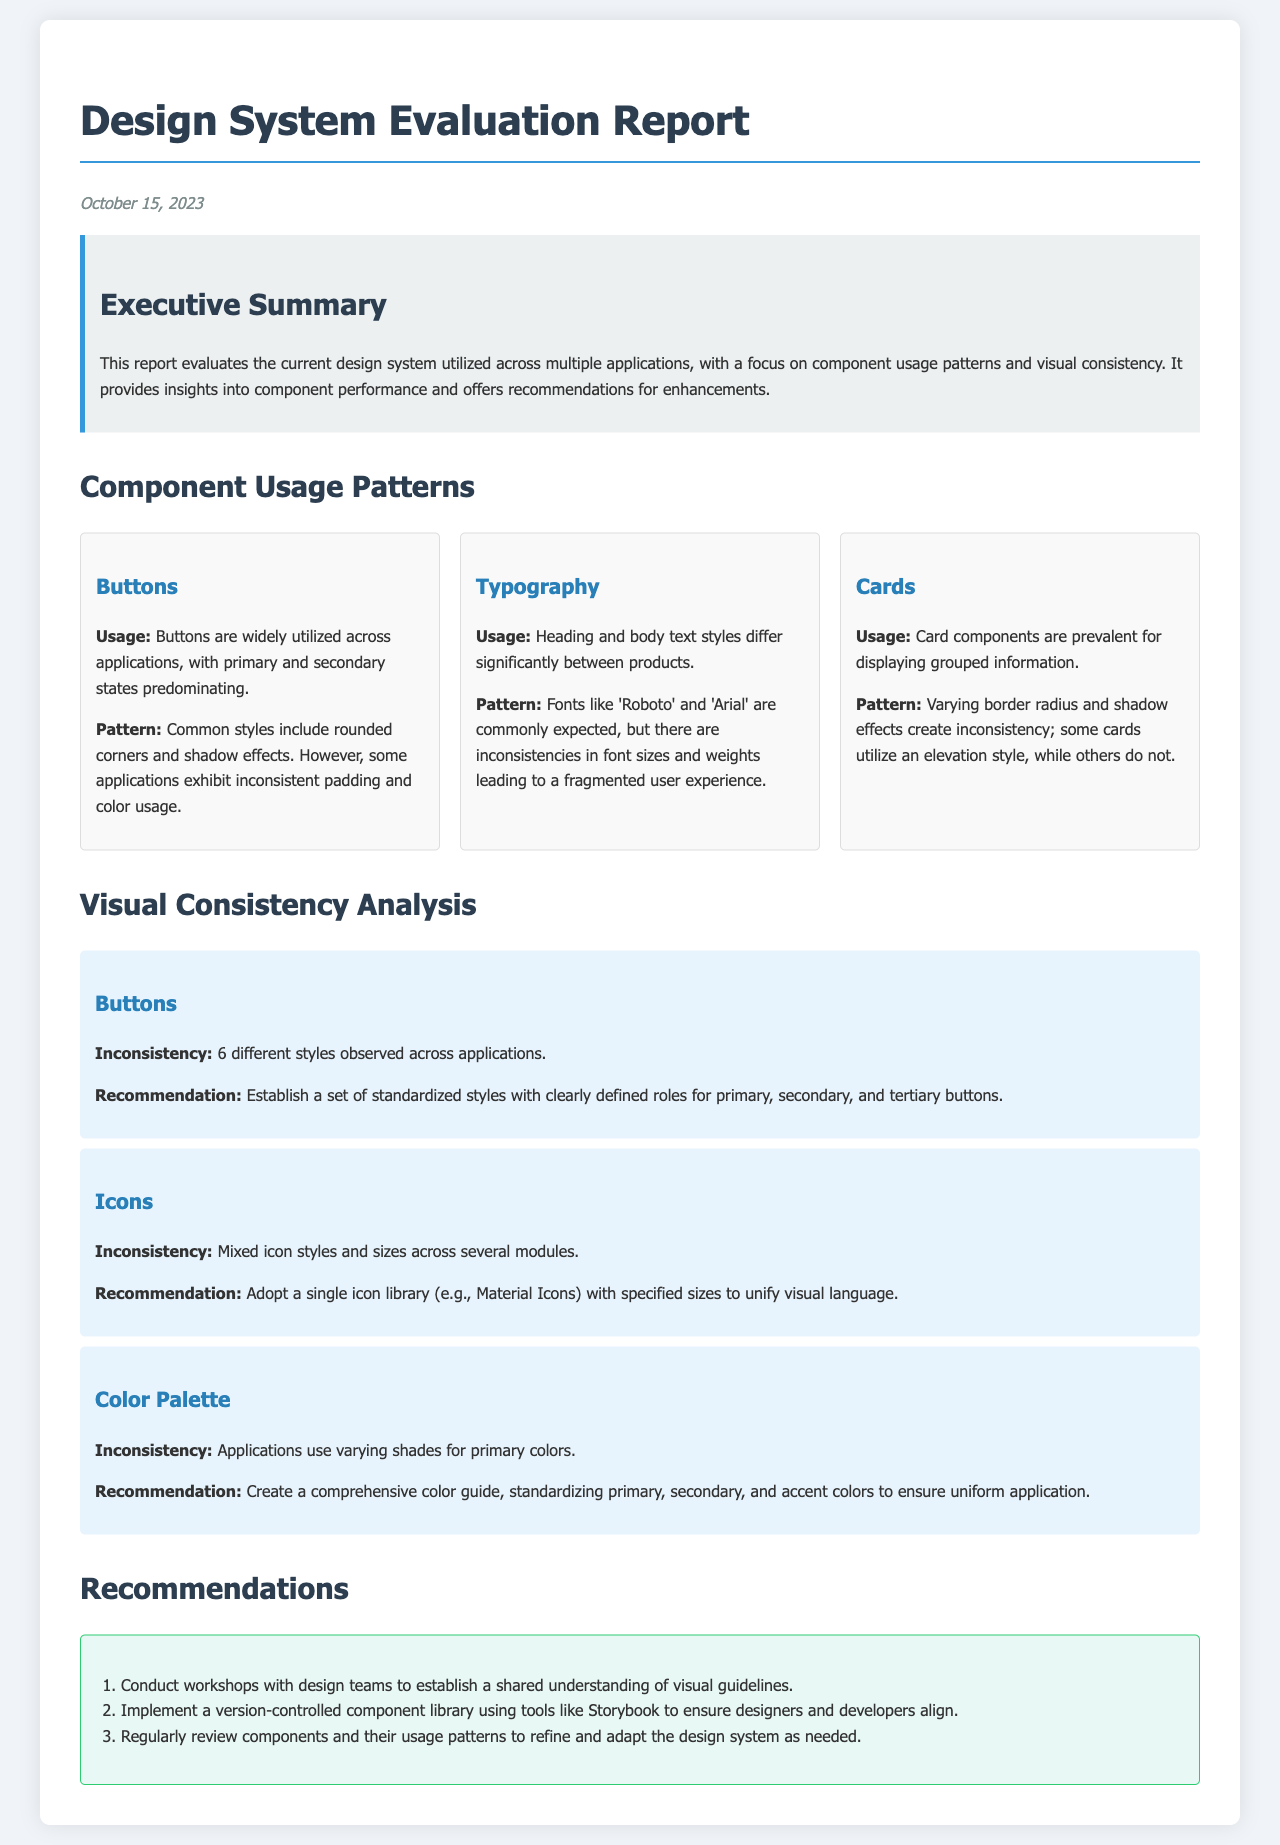What is the date of the report? The date is mentioned at the top of the document.
Answer: October 15, 2023 How many different button styles are observed across applications? This number is stated in the findings section of the report.
Answer: 6 What are the two commonly expected fonts mentioned in the document? The document lists these fonts in the typography section.
Answer: Roboto and Arial What is recommended for the color palette inconsistencies? The recommendation is found under the color palette findings section.
Answer: Create a comprehensive color guide What is the primary focus of the evaluation report? This focus is described in the executive summary.
Answer: Component usage patterns and visual consistency What tool is suggested for implementing a version-controlled component library? The suggested tool is mentioned in the recommendations section.
Answer: Storybook How many recommendations are provided in the report? This number can be found in the recommendations section.
Answer: 3 What is one of the main uses for card components according to the document? This use is indicated in the component usage section.
Answer: Displaying grouped information What color is used for the background of the executive summary? This color is specified in the style portion of the document.
Answer: Light grey 